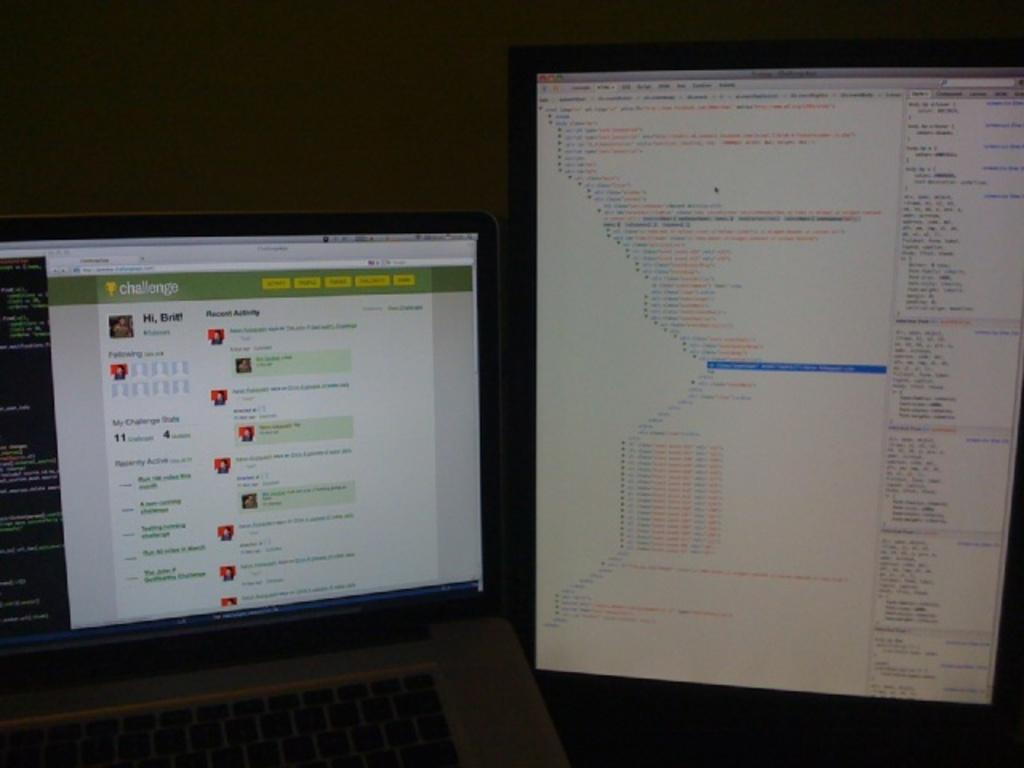<image>
Provide a brief description of the given image. two screens with one of them on a tab that says recent activity on it 